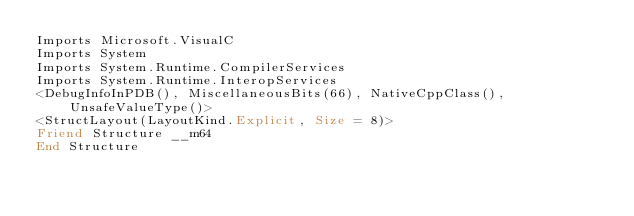Convert code to text. <code><loc_0><loc_0><loc_500><loc_500><_VisualBasic_>Imports Microsoft.VisualC
Imports System
Imports System.Runtime.CompilerServices
Imports System.Runtime.InteropServices
<DebugInfoInPDB(), MiscellaneousBits(66), NativeCppClass(), UnsafeValueType()>
<StructLayout(LayoutKind.Explicit, Size = 8)>
Friend Structure __m64
End Structure
</code> 